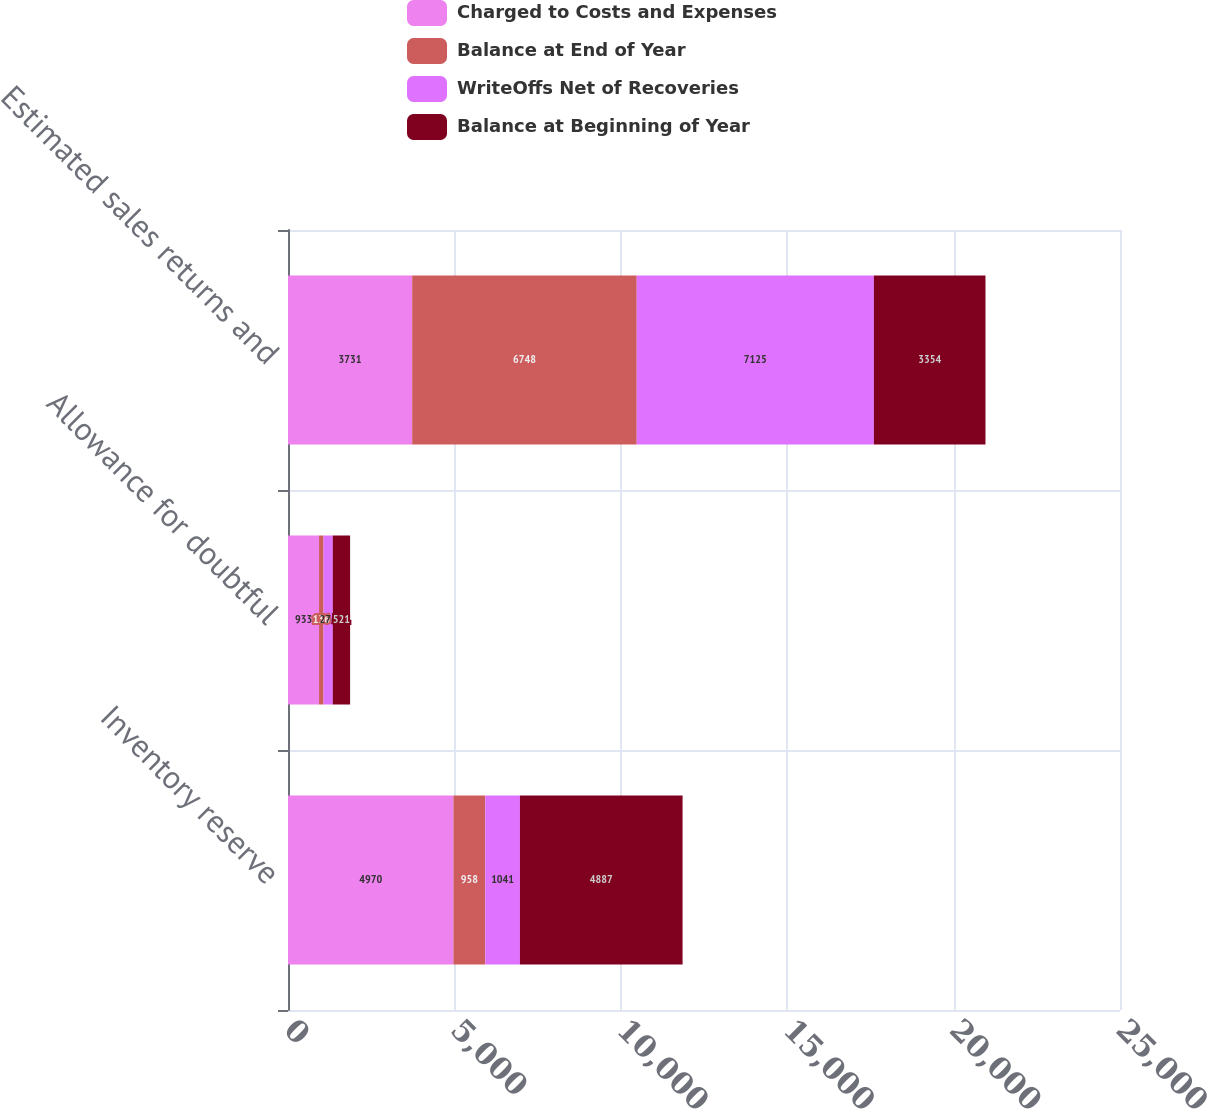Convert chart. <chart><loc_0><loc_0><loc_500><loc_500><stacked_bar_chart><ecel><fcel>Inventory reserve<fcel>Allowance for doubtful<fcel>Estimated sales returns and<nl><fcel>Charged to Costs and Expenses<fcel>4970<fcel>933<fcel>3731<nl><fcel>Balance at End of Year<fcel>958<fcel>136<fcel>6748<nl><fcel>WriteOffs Net of Recoveries<fcel>1041<fcel>276<fcel>7125<nl><fcel>Balance at Beginning of Year<fcel>4887<fcel>521<fcel>3354<nl></chart> 